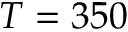<formula> <loc_0><loc_0><loc_500><loc_500>T = 3 5 0</formula> 